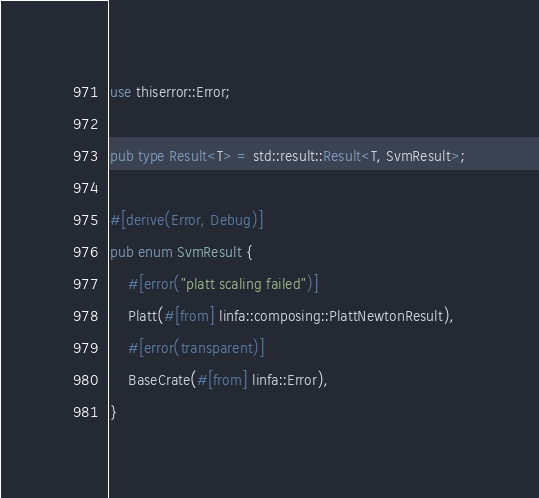Convert code to text. <code><loc_0><loc_0><loc_500><loc_500><_Rust_>use thiserror::Error;

pub type Result<T> = std::result::Result<T, SvmResult>;

#[derive(Error, Debug)]
pub enum SvmResult {
    #[error("platt scaling failed")]
    Platt(#[from] linfa::composing::PlattNewtonResult),
    #[error(transparent)]
    BaseCrate(#[from] linfa::Error),
}
</code> 